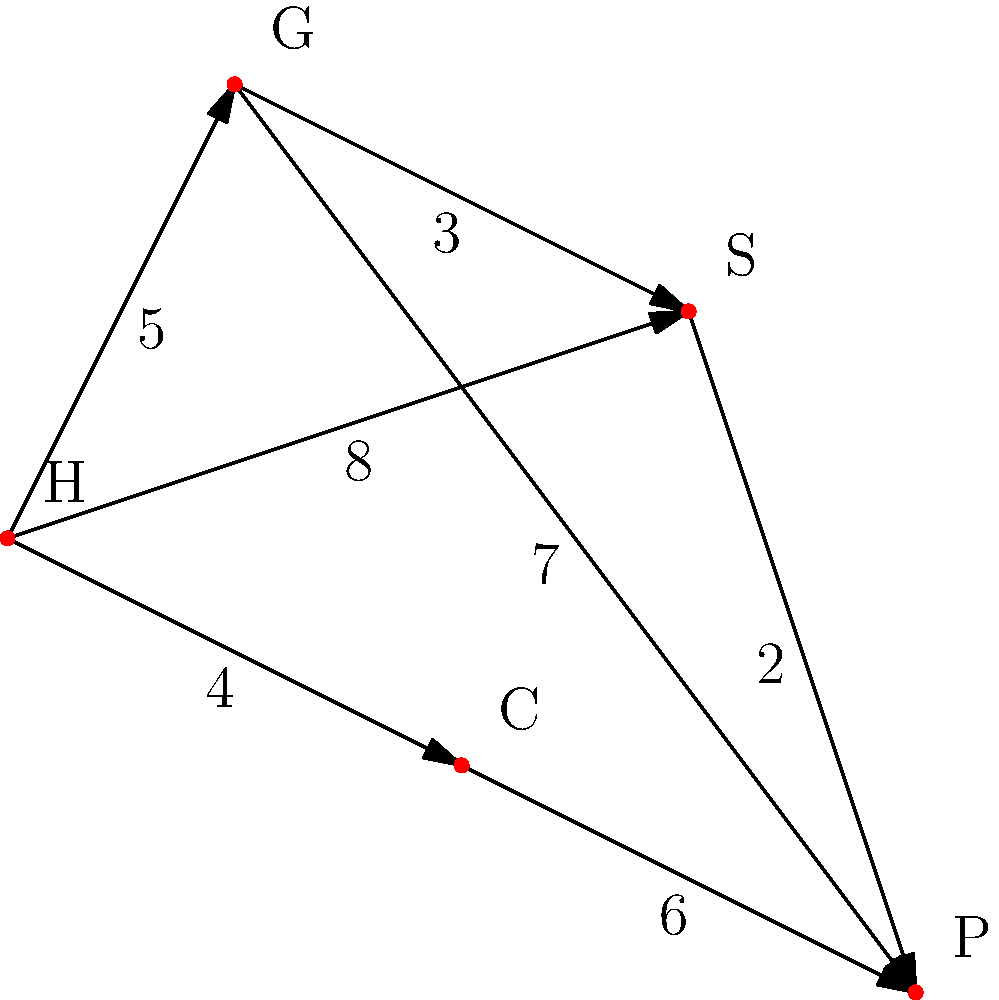As a military spouse adjusting to a new station, you're tasked with finding the most efficient route from your housing area (H) to various off-base amenities. The weighted graph represents travel times in minutes between locations: H (Housing), G (Grocery store), S (School), C (Childcare center), and P (Park). What's the minimum total travel time to visit all locations, starting and ending at H, without revisiting any location except H? To solve this problem, we need to find the shortest Hamiltonian cycle, also known as the Traveling Salesman Problem (TSP). Here's a step-by-step approach:

1. Identify all possible Hamiltonian cycles:
   H-G-S-P-C-H
   H-G-P-S-C-H
   H-C-P-S-G-H
   H-S-G-P-C-H
   H-S-P-G-C-H

2. Calculate the total travel time for each cycle:

   H-G-S-P-C-H:
   $5 + 3 + 2 + 6 + 4 = 20$ minutes

   H-G-P-S-C-H:
   $5 + 7 + 2 + 3 + 4 = 21$ minutes

   H-C-P-S-G-H:
   $4 + 6 + 2 + 3 + 5 = 20$ minutes

   H-S-G-P-C-H:
   $8 + 3 + 7 + 6 + 4 = 28$ minutes

   H-S-P-G-C-H:
   $8 + 2 + 7 + 5 + 4 = 26$ minutes

3. Compare the total travel times and select the minimum:
   The minimum total travel time is 20 minutes, which can be achieved by two routes:
   H-G-S-P-C-H or H-C-P-S-G-H

Therefore, the minimum total travel time to visit all locations, starting and ending at H, without revisiting any location except H, is 20 minutes.
Answer: 20 minutes 